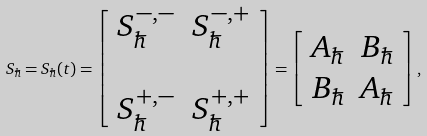<formula> <loc_0><loc_0><loc_500><loc_500>S _ { \hbar } = S _ { \hbar } ( t ) = \left [ \begin{array} { c c } S ^ { - , - } _ { \hbar } & S ^ { - , + } _ { \hbar } \\ & \\ S ^ { + , - } _ { \hbar } & S ^ { + , + } _ { \hbar } \end{array} \right ] = \left [ \begin{array} { c c } A _ { \hbar } & B _ { \hbar } \\ B _ { \hbar } & A _ { \hbar } \end{array} \right ] ,</formula> 